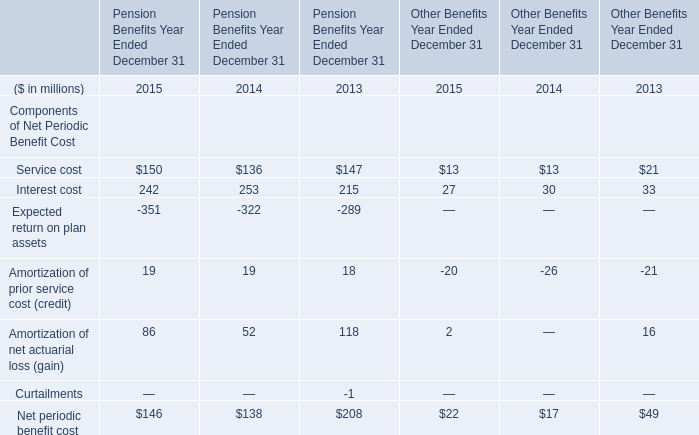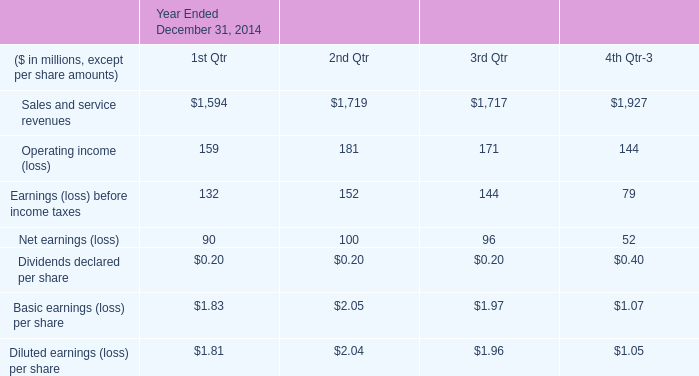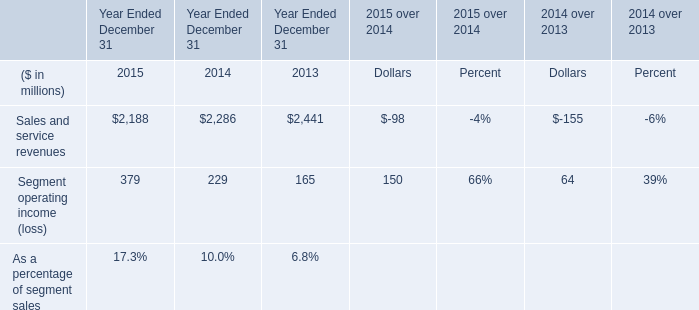How many elements for Pension Benefits Year Ended December 31 show negative value in 2015? 
Answer: 1. 